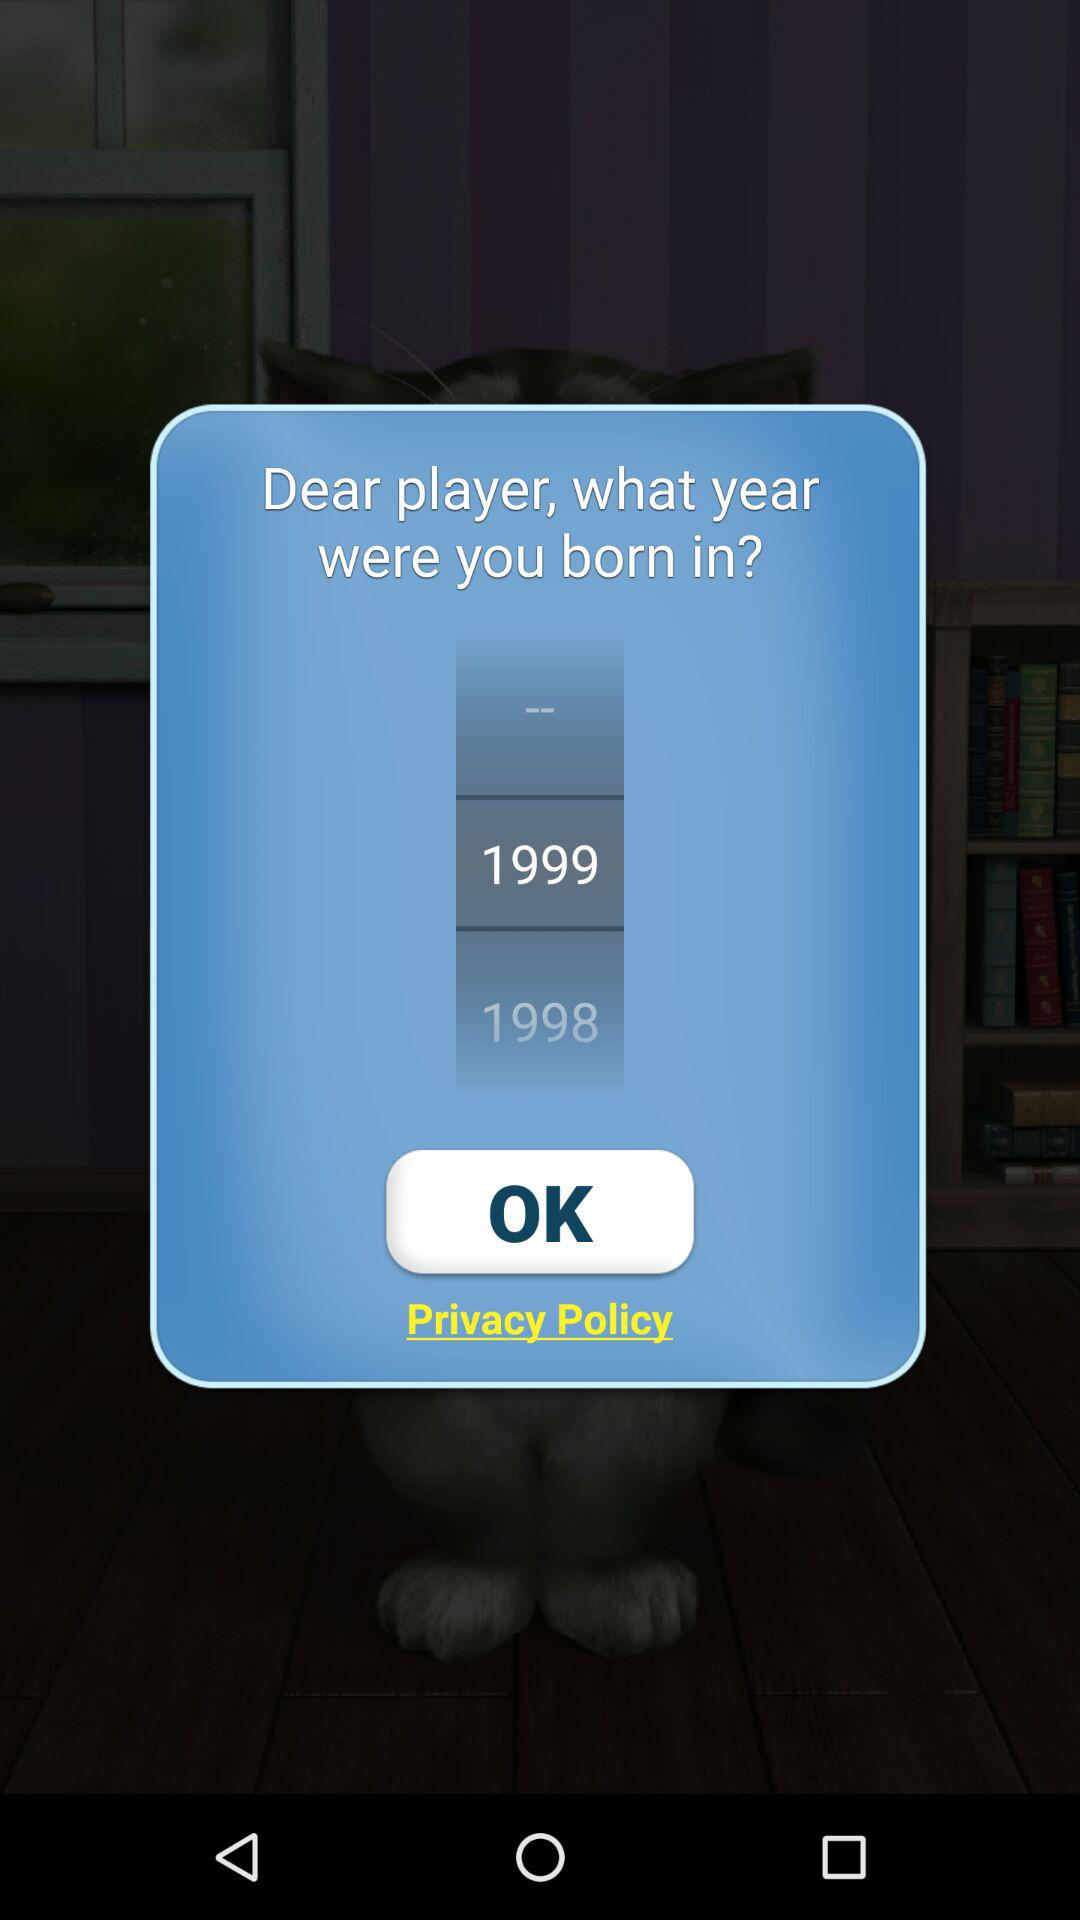How many years between 1998 and 1999?
Answer the question using a single word or phrase. 1 